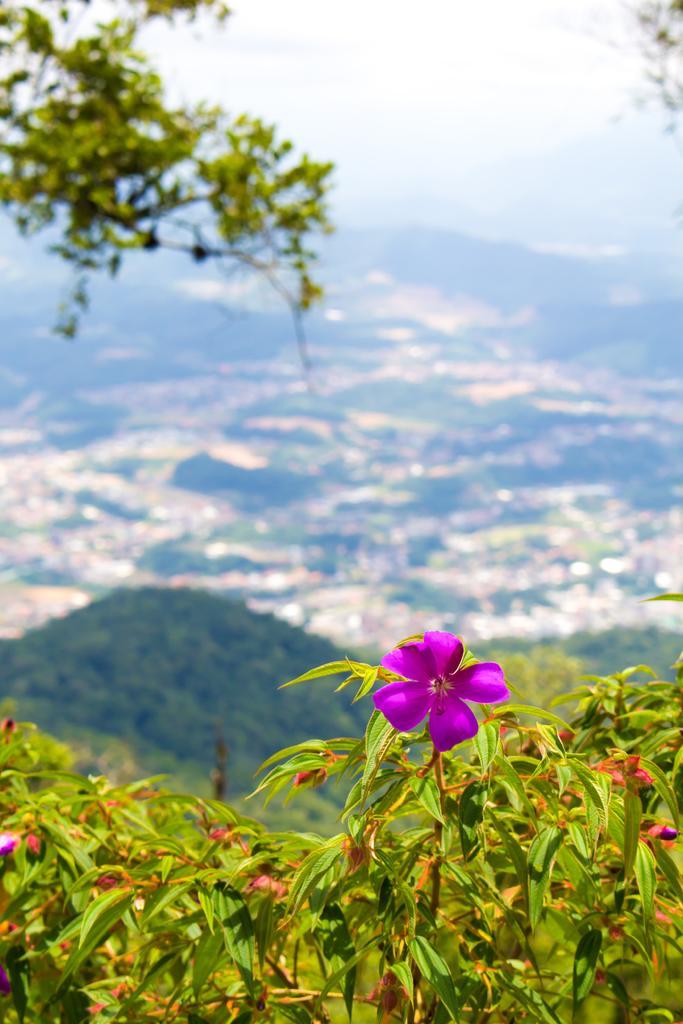Can you describe this image briefly? In this image I can see few plants and few flowers to the plants which are pink in color and in the background I can see few trees, the ground and the sky. 